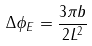<formula> <loc_0><loc_0><loc_500><loc_500>\Delta \phi _ { E } = \frac { 3 \pi b } { 2 L ^ { 2 } }</formula> 